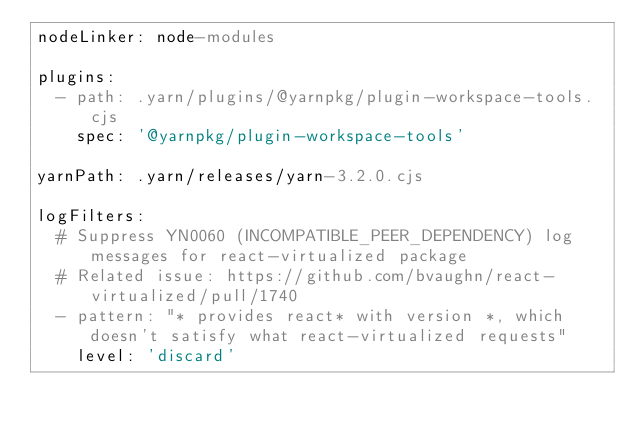Convert code to text. <code><loc_0><loc_0><loc_500><loc_500><_YAML_>nodeLinker: node-modules

plugins:
  - path: .yarn/plugins/@yarnpkg/plugin-workspace-tools.cjs
    spec: '@yarnpkg/plugin-workspace-tools'

yarnPath: .yarn/releases/yarn-3.2.0.cjs

logFilters:
  # Suppress YN0060 (INCOMPATIBLE_PEER_DEPENDENCY) log messages for react-virtualized package
  # Related issue: https://github.com/bvaughn/react-virtualized/pull/1740
  - pattern: "* provides react* with version *, which doesn't satisfy what react-virtualized requests"
    level: 'discard'
</code> 